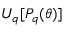<formula> <loc_0><loc_0><loc_500><loc_500>U _ { q } [ P _ { q } ( \theta ) ]</formula> 